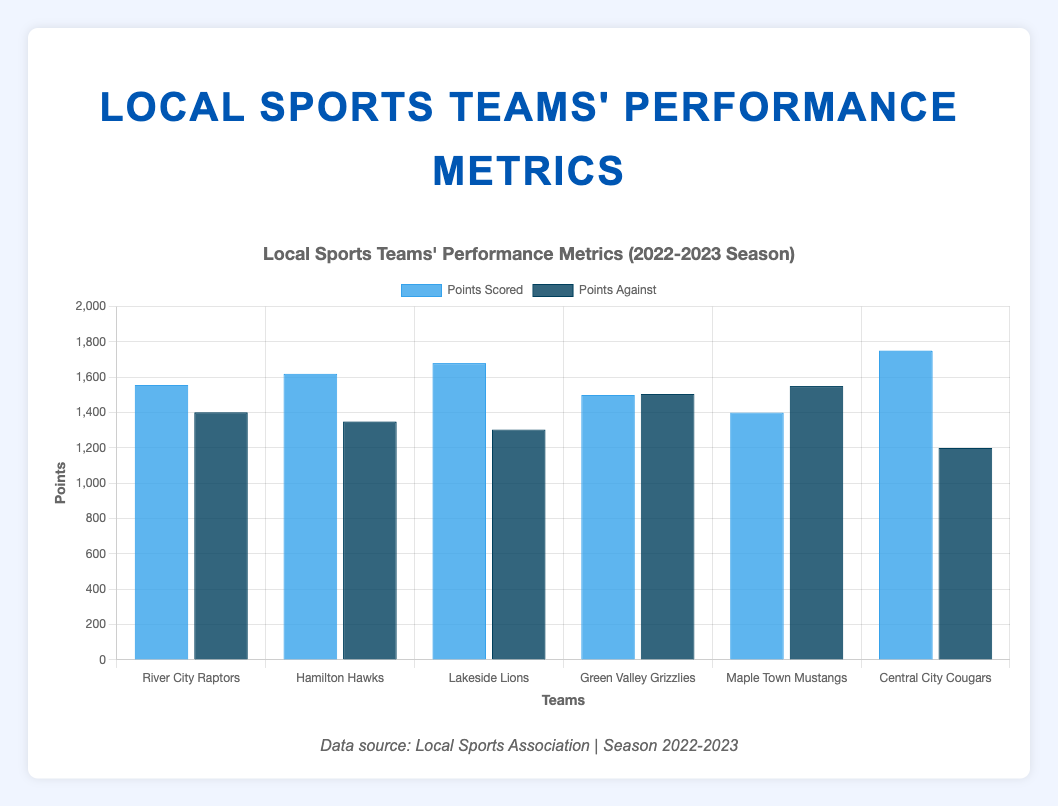Which team scored the highest points? Look for the tallest blue bar representing "Points Scored." The Central City Cougars have the tallest blue bar, indicating they scored the highest points.
Answer: Central City Cougars Which team has the highest points against? Look for the tallest dark blue bar representing "Points Against." The Maple Town Mustangs have the tallest dark blue bar, indicating they have the highest points against.
Answer: Maple Town Mustangs Which team has the most significant difference between points scored and points against? Calculate the differences between points scored and points against for each team and find the largest absolute value. The Central City Cougars have the largest difference: 1750 - 1200 = 550.
Answer: Central City Cougars How many teams scored more points than they conceded? Compare the "Points Scored" (blue bars) and "Points Against" (dark blue bars) for each team. The River City Raptors, Hamilton Hawks, Lakeside Lions, and Central City Cougars scored more points than they conceded.
Answer: 4 Which team has an equal number of wins and losses? Look for the team where the number of wins is equal to the number of losses. The Green Valley Grizzlies have 15 wins and 15 losses.
Answer: Green Valley Grizzlies What is the average number of points scored across all teams? Sum the points scored by all teams and divide by the number of teams. (1556 + 1620 + 1680 + 1500 + 1400 + 1750) / 6 = 9506 / 6 = 1584.33
Answer: 1584.33 What is the total number of games played by all teams combined? Each team played 30 games, so multiply the number of teams by 30. 6 teams * 30 games = 180 games
Answer: 180 Which team has the lowest points scored? Look for the shortest blue bar representing "Points Scored." The Maple Town Mustangs have the shortest blue bar, indicating they scored the lowest points.
Answer: Maple Town Mustangs Which two teams have the closest points scored? Compare the points scored by each team and find the smallest difference. The Green Valley Grizzlies and River City Raptors have the closest points scored:
Answer: 1556 and 1500 What is the median points scored by the teams? List the points scored in ascending order and find the middle value. The sorted list is 1400, 1500, 1556, 1620, 1680, 1750. The median is (1556 + 1620) / 2 = 1588.
Answer: 1588 